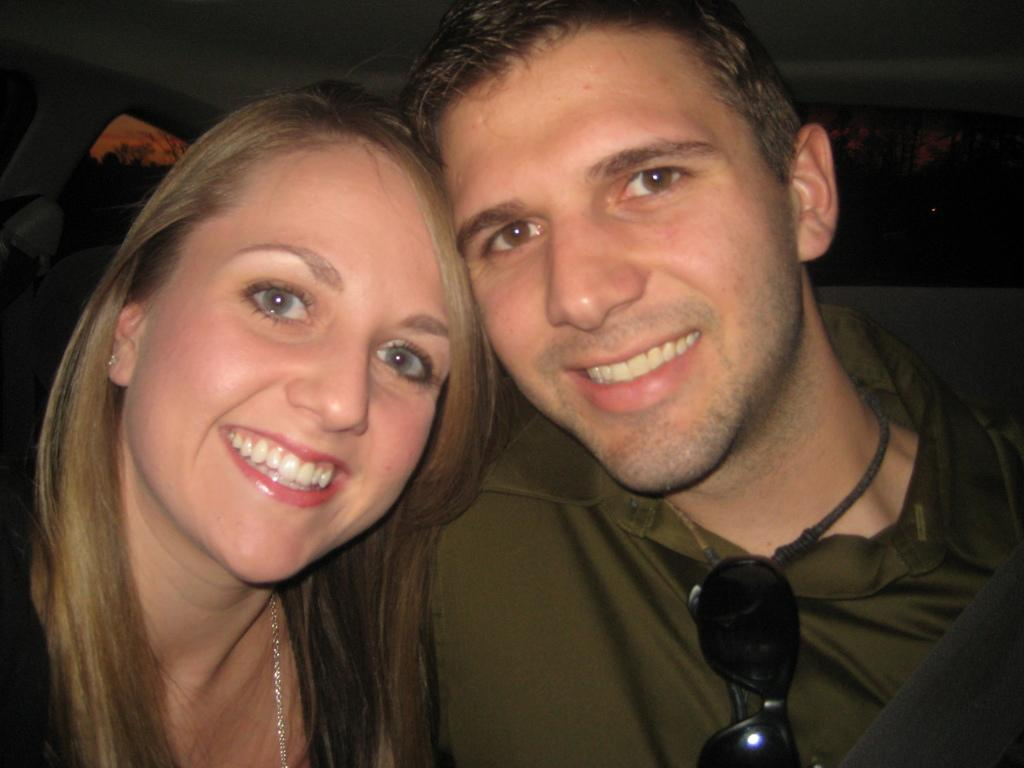How many people are in the image? There is a man and a woman in the image. What expressions do the people in the image have? Both the man and the woman are smiling. What type of accessory is present in the image? Goggles are present in the image. What can be seen in the background of the image? There are trees, objects, and the sky visible in the background of the image. What type of hole can be seen in the image? There is no hole present in the image. What type of coil is being used by the man in the image? There is no coil present in the image, and the man's actions are not described in the provided facts. 